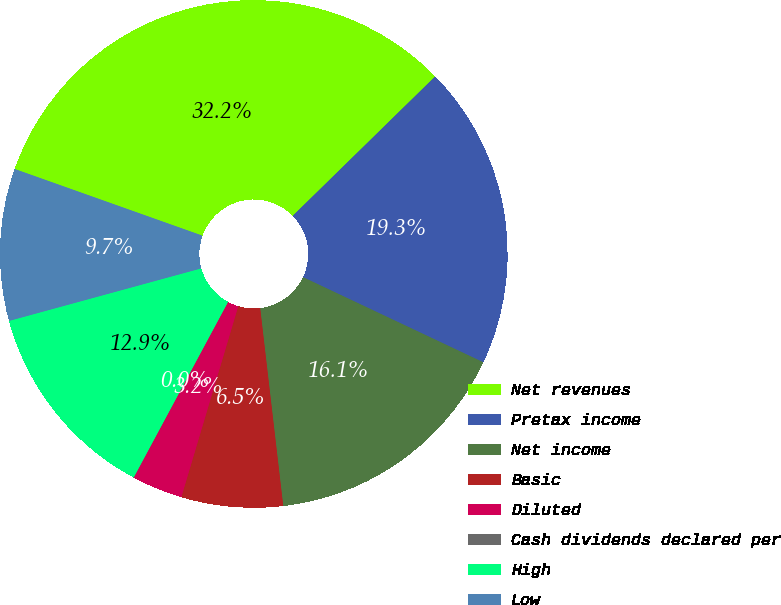Convert chart. <chart><loc_0><loc_0><loc_500><loc_500><pie_chart><fcel>Net revenues<fcel>Pretax income<fcel>Net income<fcel>Basic<fcel>Diluted<fcel>Cash dividends declared per<fcel>High<fcel>Low<nl><fcel>32.24%<fcel>19.35%<fcel>16.13%<fcel>6.46%<fcel>3.23%<fcel>0.01%<fcel>12.9%<fcel>9.68%<nl></chart> 